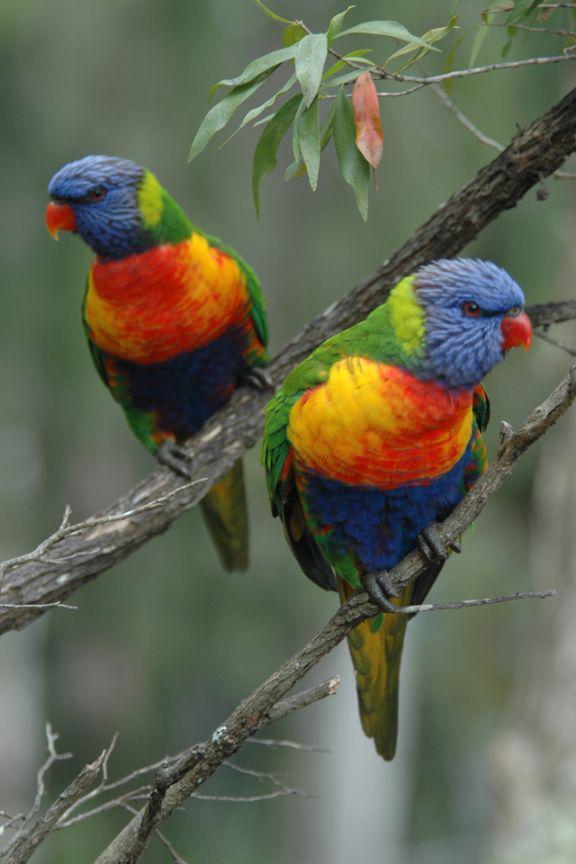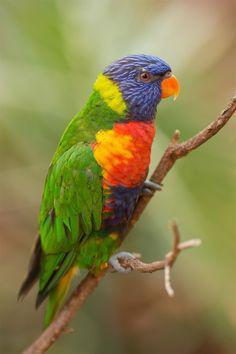The first image is the image on the left, the second image is the image on the right. Assess this claim about the two images: "There are three birds perched on something.". Correct or not? Answer yes or no. Yes. The first image is the image on the left, the second image is the image on the right. Given the left and right images, does the statement "There are three birds" hold true? Answer yes or no. Yes. 